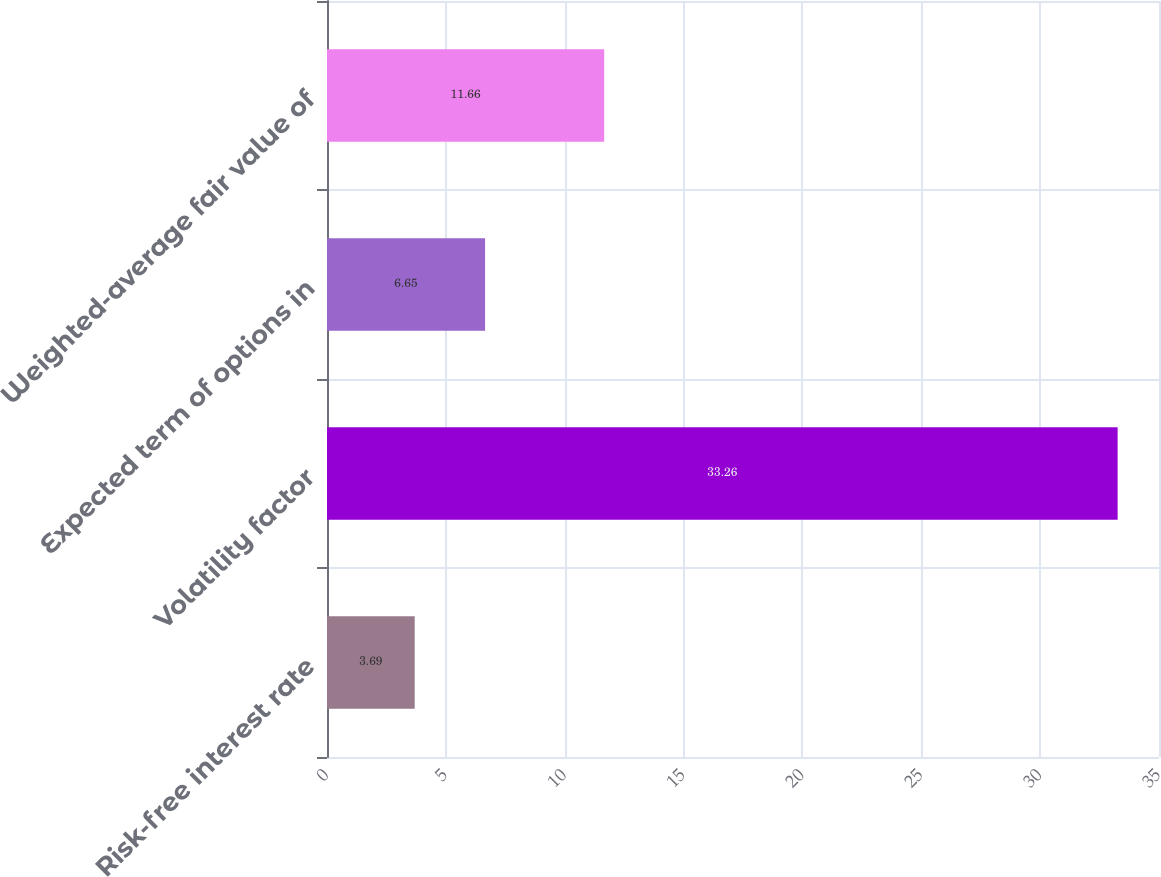<chart> <loc_0><loc_0><loc_500><loc_500><bar_chart><fcel>Risk-free interest rate<fcel>Volatility factor<fcel>Expected term of options in<fcel>Weighted-average fair value of<nl><fcel>3.69<fcel>33.26<fcel>6.65<fcel>11.66<nl></chart> 